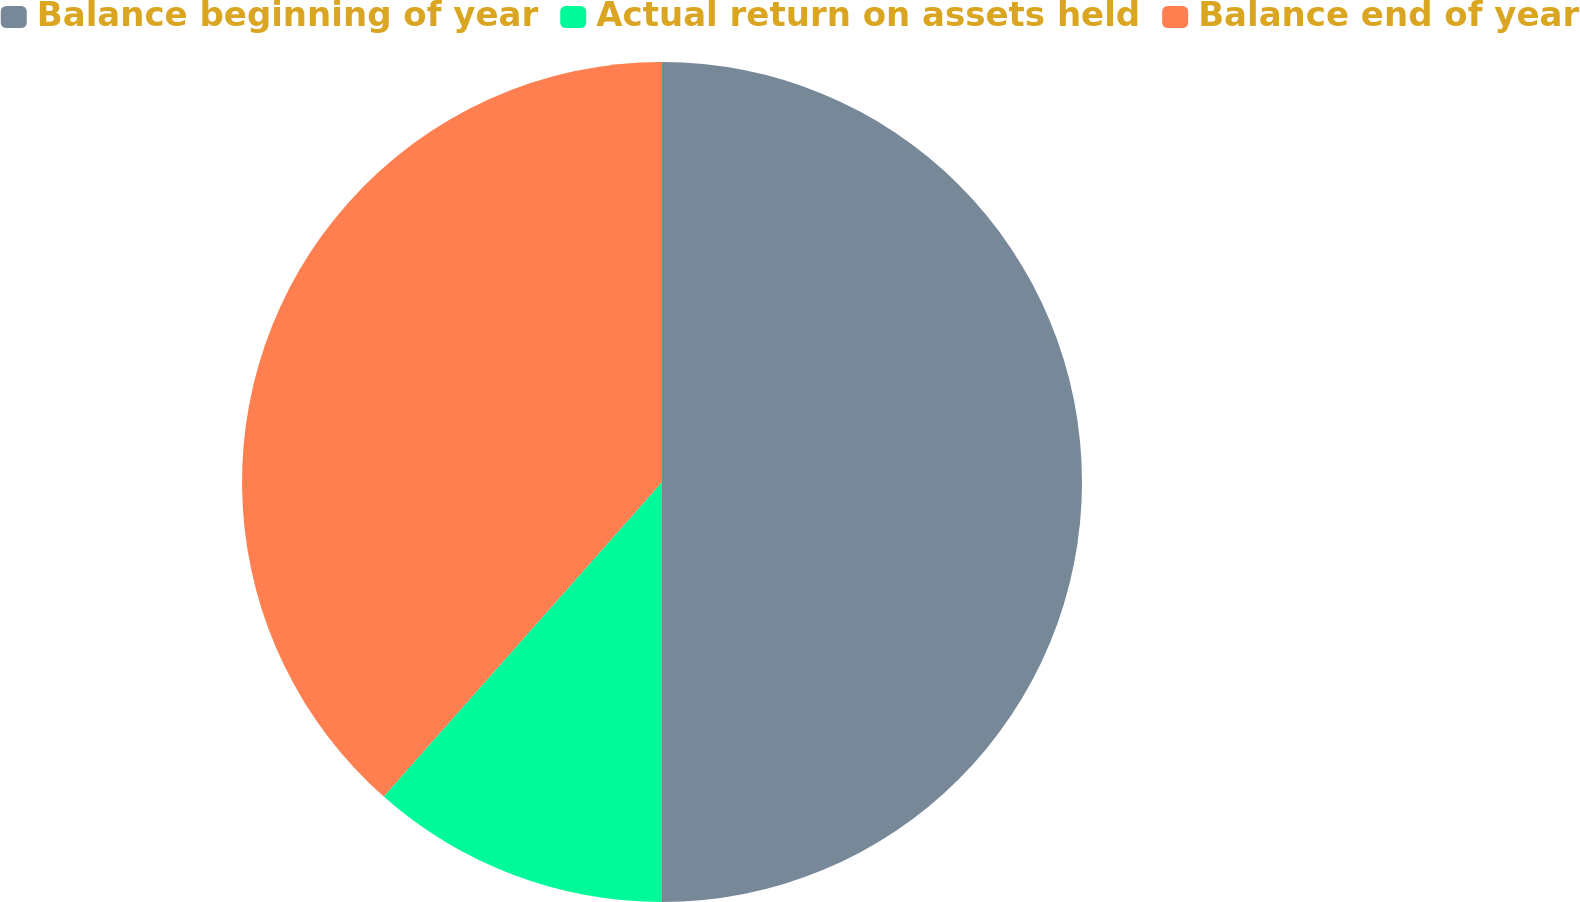Convert chart. <chart><loc_0><loc_0><loc_500><loc_500><pie_chart><fcel>Balance beginning of year<fcel>Actual return on assets held<fcel>Balance end of year<nl><fcel>50.0%<fcel>11.53%<fcel>38.47%<nl></chart> 